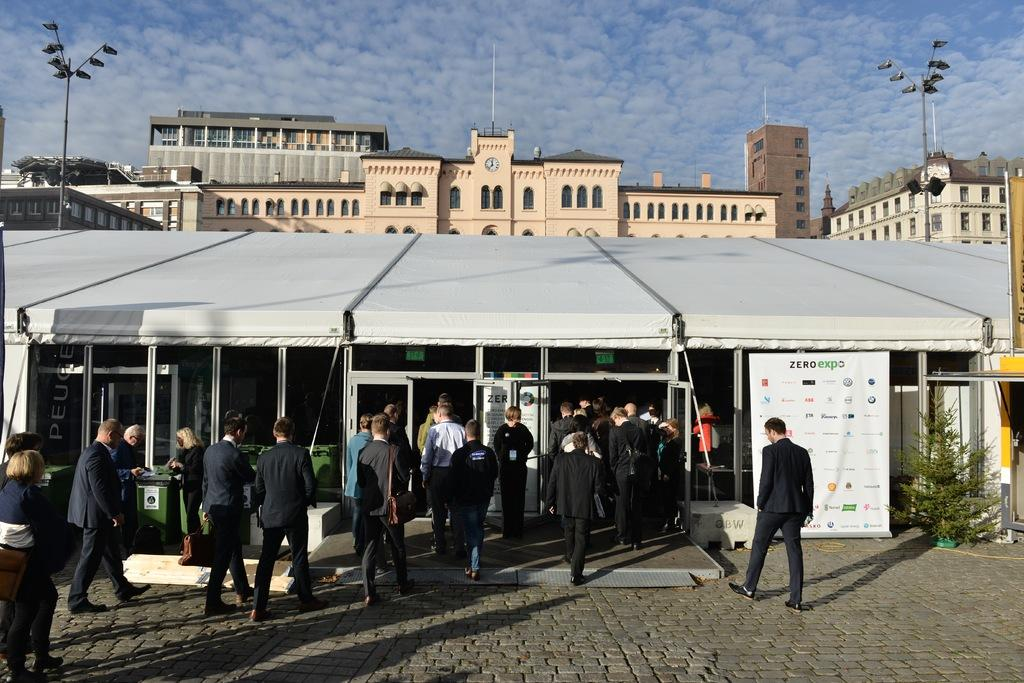What can be seen in the image? There are people, stories, a banner, a plant, dustbins, buildings, street lights, trees, and a cloudy sky visible in the image. What might the stories in the image be about? The stories in the image could be about various topics, but without more context, it's impossible to determine their content. Where is the banner located in the image? The banner is in the image, but its exact location cannot be determined without more information. What type of plant is present in the image? The type of plant cannot be determined from the image alone. What is the purpose of the dustbins in the image? The dustbins are likely for waste disposal, but their specific purpose cannot be determined without more context. What can be seen in the background of the image? In the background of the image, there are buildings, street lights, trees, and a cloudy sky. What type of copper is used to create the behavior of the point in the image? There is no copper, behavior, or point present in the image. 